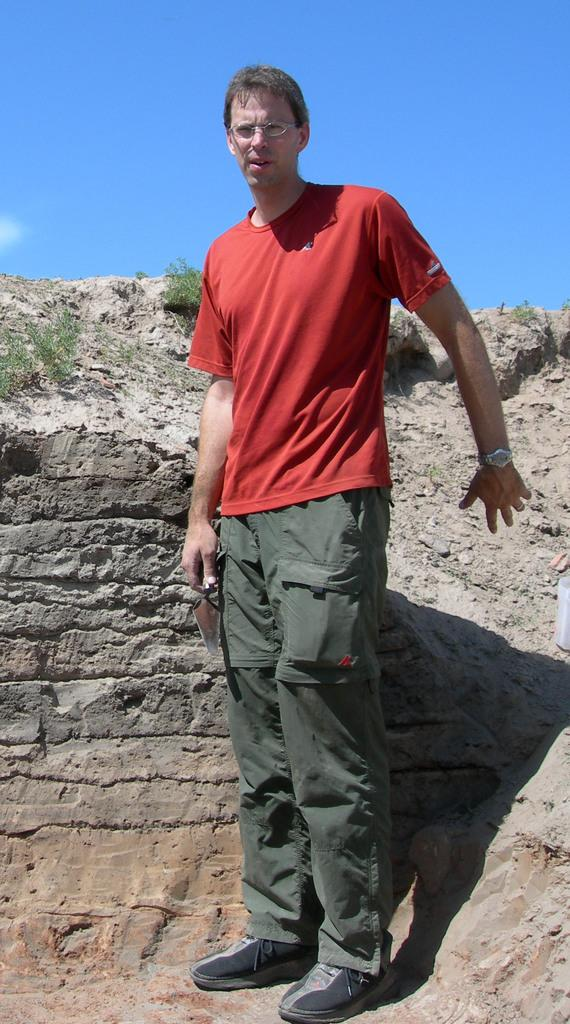Who is present in the image? There is a man standing in the image. What can be seen in the background of the image? The sky is visible in the background of the image. What type of instrument is being advertised in the image? There is no instrument being advertised in the image; it only features a man standing and the sky in the background. 